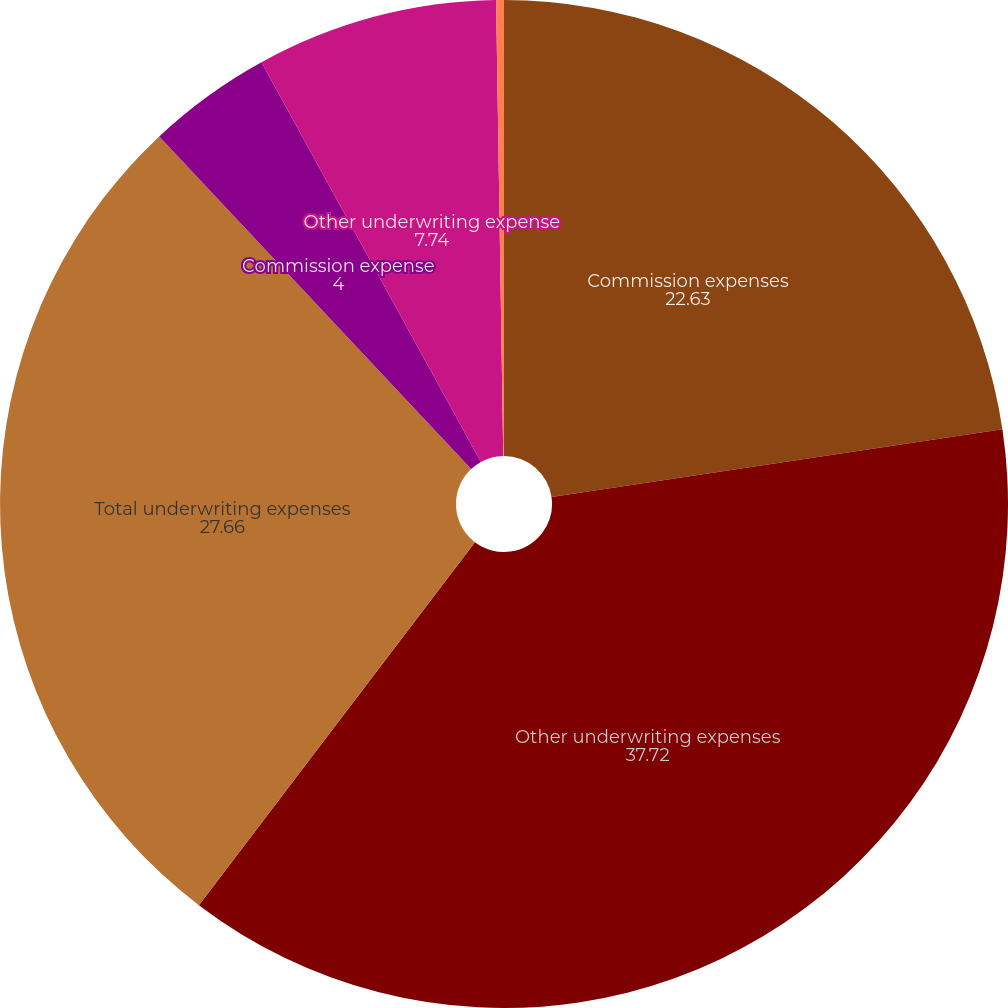Convert chart to OTSL. <chart><loc_0><loc_0><loc_500><loc_500><pie_chart><fcel>Commission expenses<fcel>Other underwriting expenses<fcel>Total underwriting expenses<fcel>Commission expense<fcel>Other underwriting expense<fcel>Total underwriting expense<nl><fcel>22.63%<fcel>37.72%<fcel>27.66%<fcel>4.0%<fcel>7.74%<fcel>0.25%<nl></chart> 